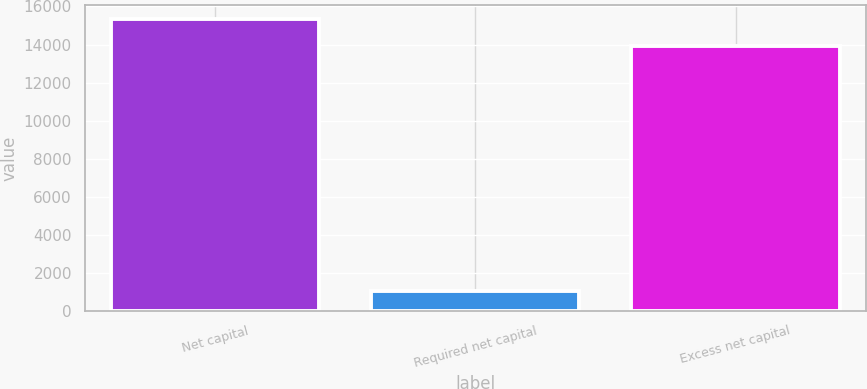Convert chart to OTSL. <chart><loc_0><loc_0><loc_500><loc_500><bar_chart><fcel>Net capital<fcel>Required net capital<fcel>Excess net capital<nl><fcel>15327.4<fcel>1048<fcel>13934<nl></chart> 